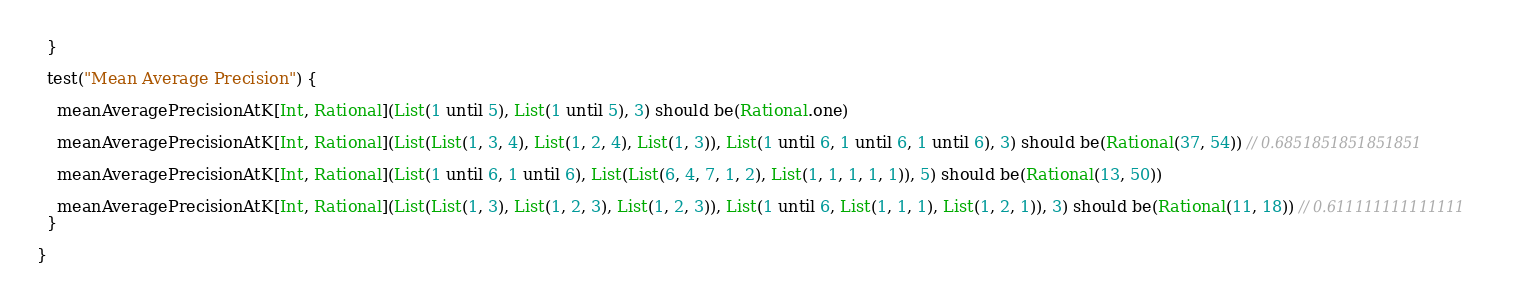Convert code to text. <code><loc_0><loc_0><loc_500><loc_500><_Scala_>  }

  test("Mean Average Precision") {

    meanAveragePrecisionAtK[Int, Rational](List(1 until 5), List(1 until 5), 3) should be(Rational.one)

    meanAveragePrecisionAtK[Int, Rational](List(List(1, 3, 4), List(1, 2, 4), List(1, 3)), List(1 until 6, 1 until 6, 1 until 6), 3) should be(Rational(37, 54)) // 0.6851851851851851

    meanAveragePrecisionAtK[Int, Rational](List(1 until 6, 1 until 6), List(List(6, 4, 7, 1, 2), List(1, 1, 1, 1, 1)), 5) should be(Rational(13, 50))

    meanAveragePrecisionAtK[Int, Rational](List(List(1, 3), List(1, 2, 3), List(1, 2, 3)), List(1 until 6, List(1, 1, 1), List(1, 2, 1)), 3) should be(Rational(11, 18)) // 0.611111111111111
  }

}
</code> 